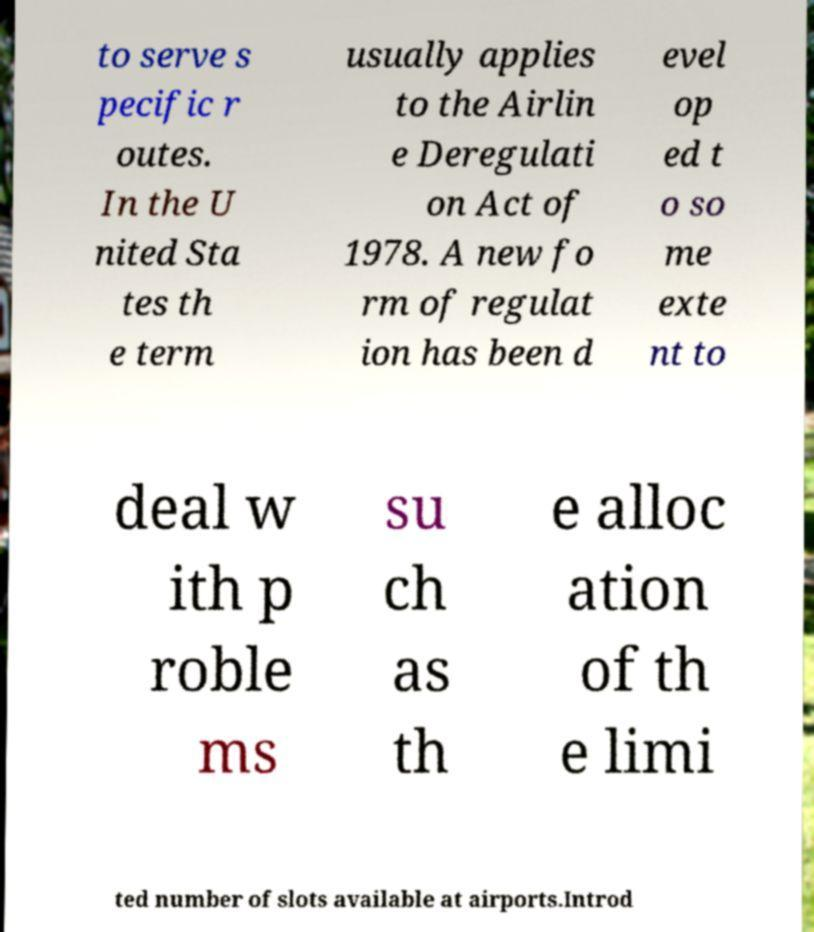Please read and relay the text visible in this image. What does it say? to serve s pecific r outes. In the U nited Sta tes th e term usually applies to the Airlin e Deregulati on Act of 1978. A new fo rm of regulat ion has been d evel op ed t o so me exte nt to deal w ith p roble ms su ch as th e alloc ation of th e limi ted number of slots available at airports.Introd 